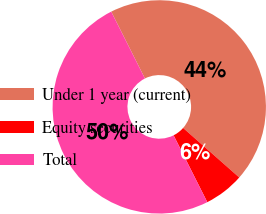<chart> <loc_0><loc_0><loc_500><loc_500><pie_chart><fcel>Under 1 year (current)<fcel>Equity securities<fcel>Total<nl><fcel>43.94%<fcel>6.06%<fcel>50.0%<nl></chart> 